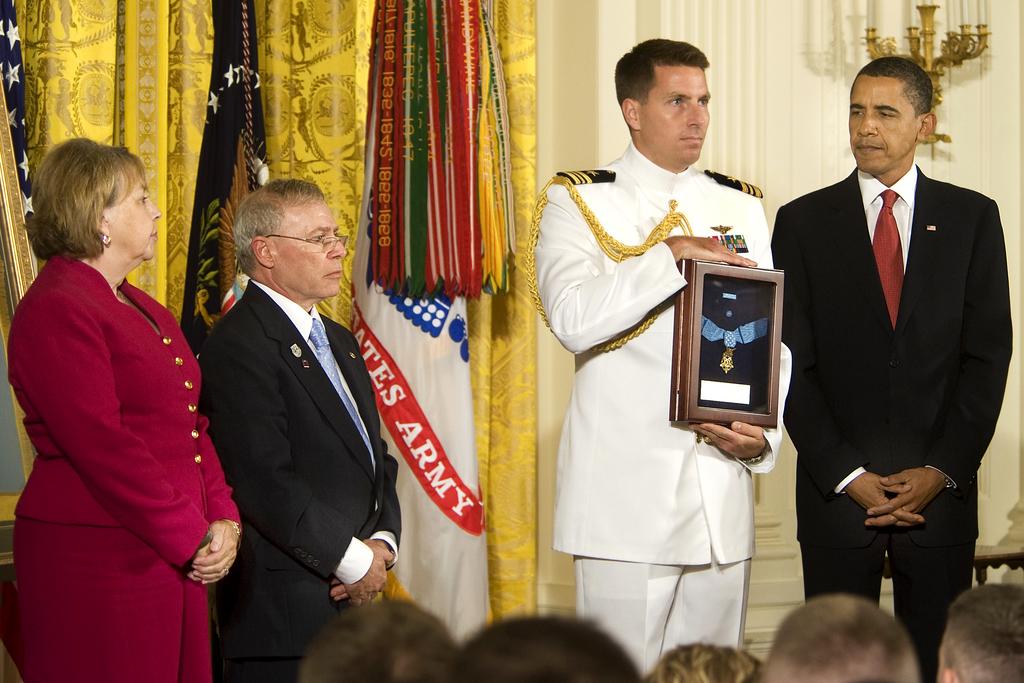What four letter word is clearly visible on the white flag between these people?
Your answer should be very brief. Army. Is this for an army service member?
Your response must be concise. Yes. 